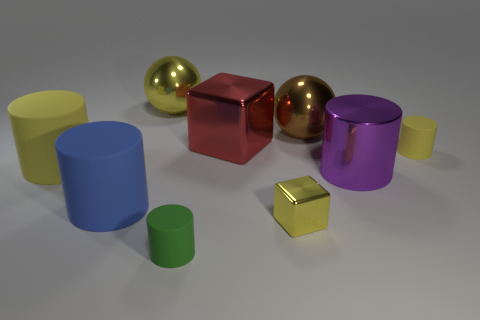Subtract all purple cylinders. How many cylinders are left? 4 Subtract all blue cylinders. How many cylinders are left? 4 Subtract all cyan cylinders. Subtract all yellow cubes. How many cylinders are left? 5 Subtract all spheres. How many objects are left? 7 Subtract 2 yellow cylinders. How many objects are left? 7 Subtract all red cylinders. Subtract all large cylinders. How many objects are left? 6 Add 3 large purple objects. How many large purple objects are left? 4 Add 1 small yellow metal objects. How many small yellow metal objects exist? 2 